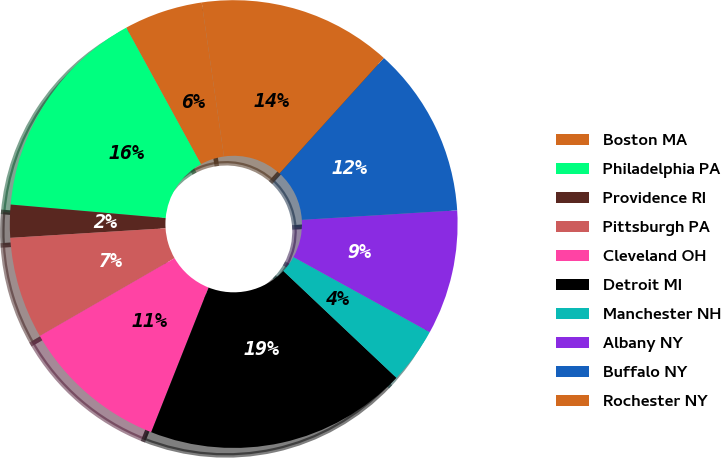Convert chart. <chart><loc_0><loc_0><loc_500><loc_500><pie_chart><fcel>Boston MA<fcel>Philadelphia PA<fcel>Providence RI<fcel>Pittsburgh PA<fcel>Cleveland OH<fcel>Detroit MI<fcel>Manchester NH<fcel>Albany NY<fcel>Buffalo NY<fcel>Rochester NY<nl><fcel>5.69%<fcel>15.64%<fcel>2.37%<fcel>7.35%<fcel>10.66%<fcel>18.96%<fcel>4.03%<fcel>9.0%<fcel>12.32%<fcel>13.98%<nl></chart> 